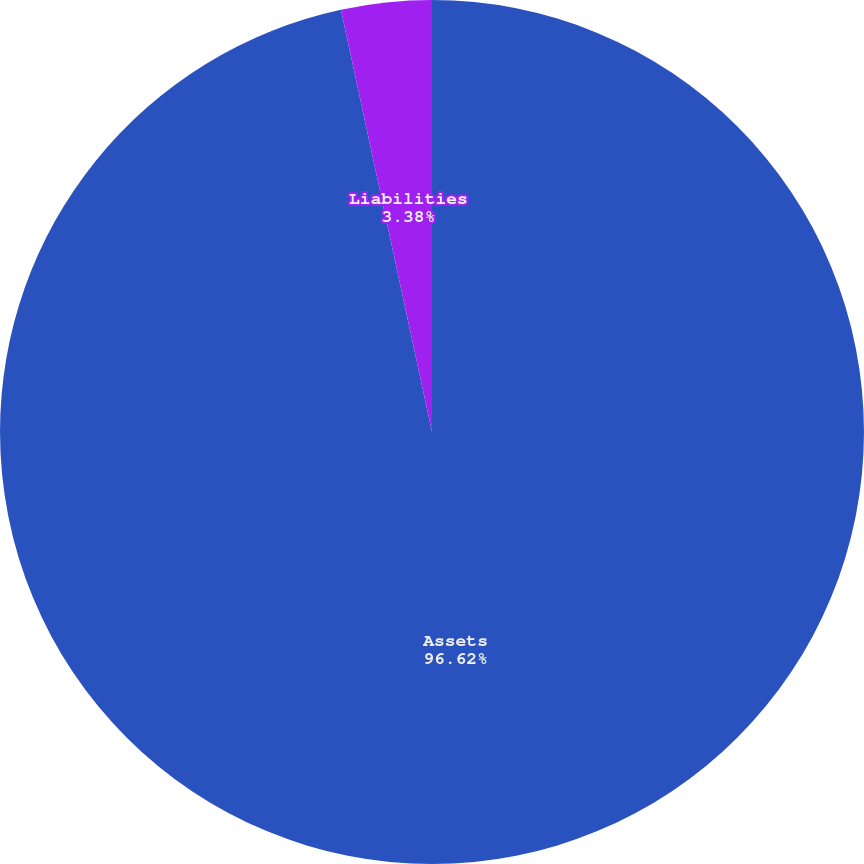Convert chart. <chart><loc_0><loc_0><loc_500><loc_500><pie_chart><fcel>Assets<fcel>Liabilities<nl><fcel>96.62%<fcel>3.38%<nl></chart> 